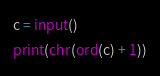<code> <loc_0><loc_0><loc_500><loc_500><_Python_>c = input()
print(chr(ord(c) + 1))</code> 